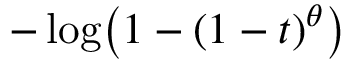Convert formula to latex. <formula><loc_0><loc_0><loc_500><loc_500>- \log \, \left ( 1 - ( 1 - t ) ^ { \theta } \right )</formula> 